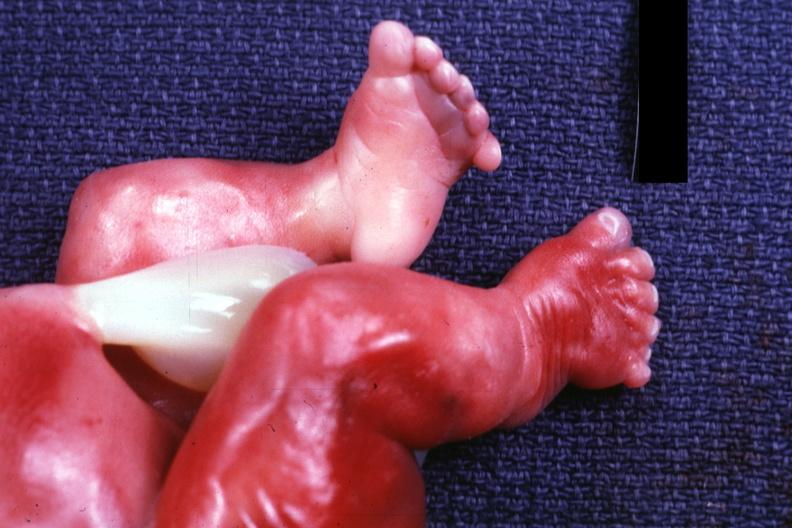re aldactone bodies present?
Answer the question using a single word or phrase. No 